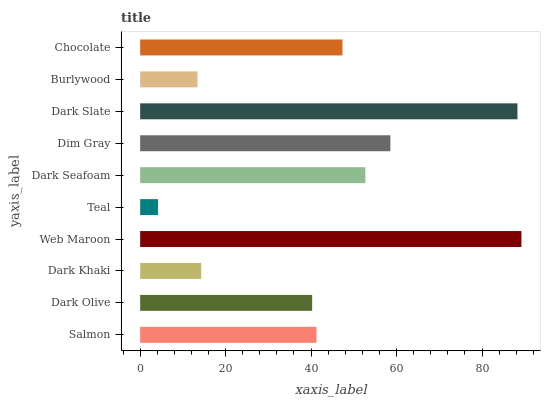Is Teal the minimum?
Answer yes or no. Yes. Is Web Maroon the maximum?
Answer yes or no. Yes. Is Dark Olive the minimum?
Answer yes or no. No. Is Dark Olive the maximum?
Answer yes or no. No. Is Salmon greater than Dark Olive?
Answer yes or no. Yes. Is Dark Olive less than Salmon?
Answer yes or no. Yes. Is Dark Olive greater than Salmon?
Answer yes or no. No. Is Salmon less than Dark Olive?
Answer yes or no. No. Is Chocolate the high median?
Answer yes or no. Yes. Is Salmon the low median?
Answer yes or no. Yes. Is Web Maroon the high median?
Answer yes or no. No. Is Web Maroon the low median?
Answer yes or no. No. 